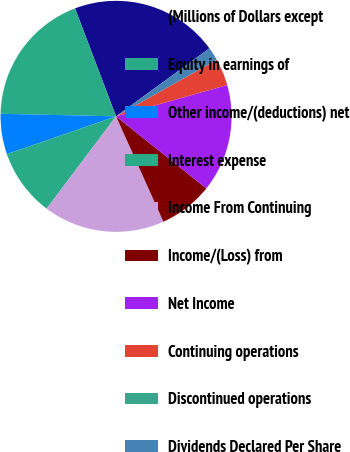Convert chart to OTSL. <chart><loc_0><loc_0><loc_500><loc_500><pie_chart><fcel>(Millions of Dollars except<fcel>Equity in earnings of<fcel>Other income/(deductions) net<fcel>Interest expense<fcel>Income From Continuing<fcel>Income/(Loss) from<fcel>Net Income<fcel>Continuing operations<fcel>Discontinued operations<fcel>Dividends Declared Per Share<nl><fcel>20.75%<fcel>18.87%<fcel>5.66%<fcel>9.43%<fcel>16.98%<fcel>7.55%<fcel>15.09%<fcel>3.77%<fcel>0.0%<fcel>1.89%<nl></chart> 